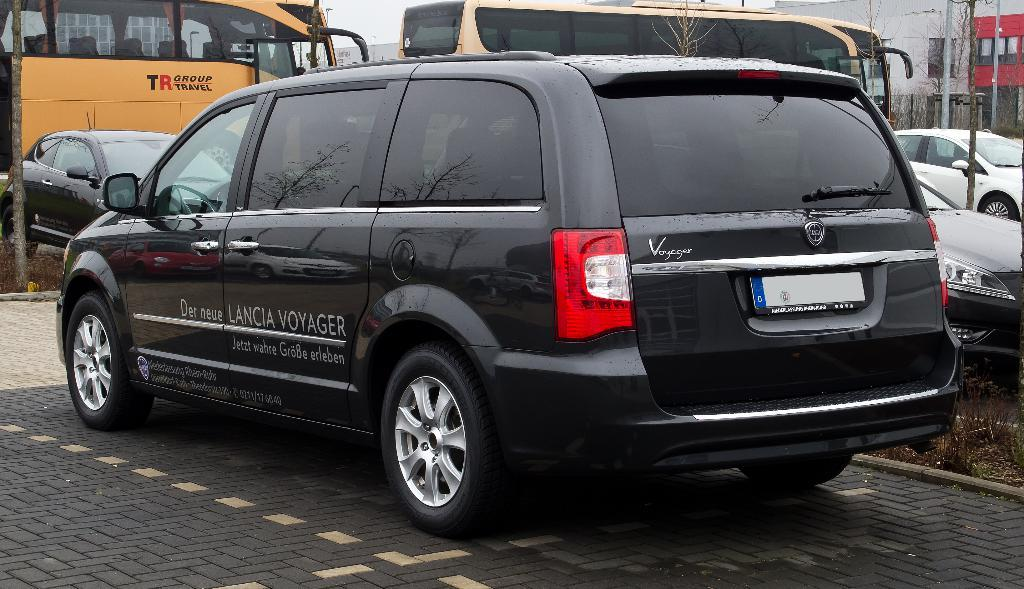What can be seen in the image in terms of transportation? There are many vehicles of different colors and sizes in the image. Where are the vehicles located? The vehicles are on a road. What type of vegetation is visible in the image? There is grass visible in the image. What else can be seen in the image besides the vehicles and grass? There are poles, buildings, and the sky visible in the image. What type of screw is holding the vehicles together in the image? There are no screws visible in the image, as the vehicles are separate entities. 